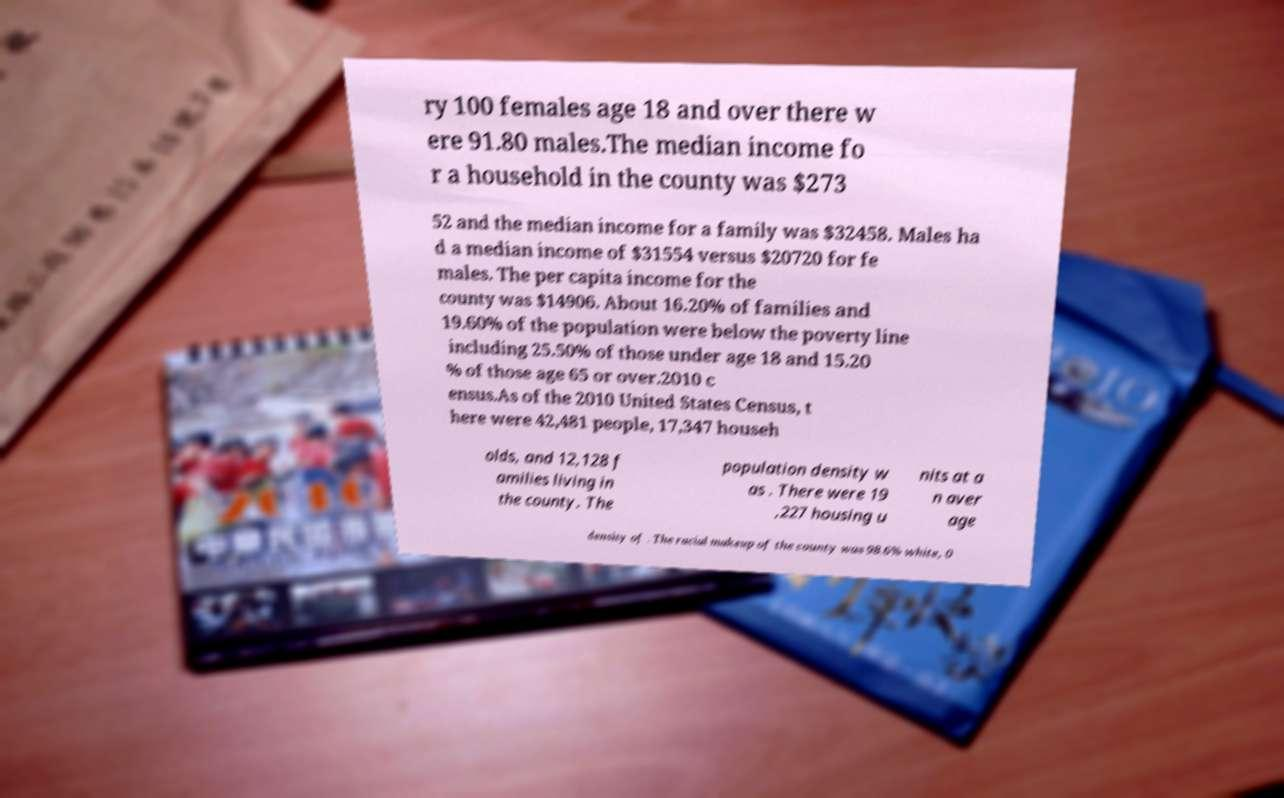Could you assist in decoding the text presented in this image and type it out clearly? ry 100 females age 18 and over there w ere 91.80 males.The median income fo r a household in the county was $273 52 and the median income for a family was $32458. Males ha d a median income of $31554 versus $20720 for fe males. The per capita income for the county was $14906. About 16.20% of families and 19.60% of the population were below the poverty line including 25.50% of those under age 18 and 15.20 % of those age 65 or over.2010 c ensus.As of the 2010 United States Census, t here were 42,481 people, 17,347 househ olds, and 12,128 f amilies living in the county. The population density w as . There were 19 ,227 housing u nits at a n aver age density of . The racial makeup of the county was 98.6% white, 0 